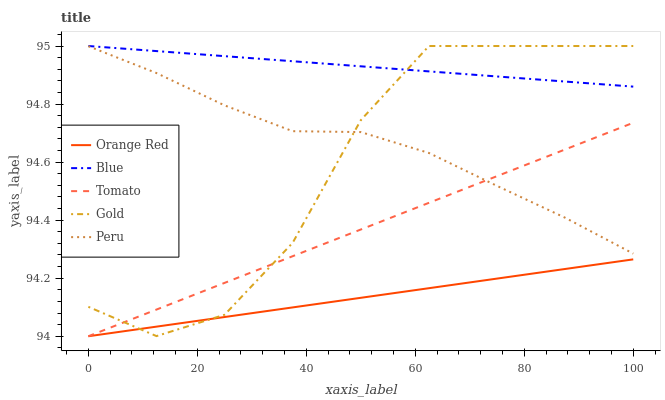Does Orange Red have the minimum area under the curve?
Answer yes or no. Yes. Does Blue have the maximum area under the curve?
Answer yes or no. Yes. Does Tomato have the minimum area under the curve?
Answer yes or no. No. Does Tomato have the maximum area under the curve?
Answer yes or no. No. Is Blue the smoothest?
Answer yes or no. Yes. Is Gold the roughest?
Answer yes or no. Yes. Is Tomato the smoothest?
Answer yes or no. No. Is Tomato the roughest?
Answer yes or no. No. Does Peru have the lowest value?
Answer yes or no. No. Does Gold have the highest value?
Answer yes or no. Yes. Does Tomato have the highest value?
Answer yes or no. No. Is Peru less than Blue?
Answer yes or no. Yes. Is Blue greater than Orange Red?
Answer yes or no. Yes. Does Peru intersect Blue?
Answer yes or no. No. 